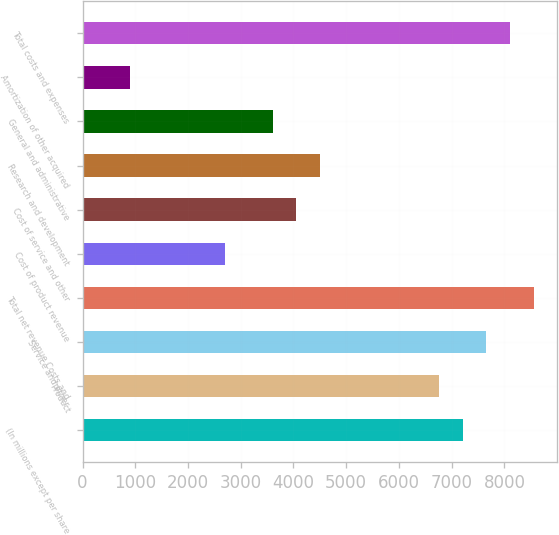Convert chart to OTSL. <chart><loc_0><loc_0><loc_500><loc_500><bar_chart><fcel>(In millions except per share<fcel>Product<fcel>Service and other<fcel>Total net revenue Costs and<fcel>Cost of product revenue<fcel>Cost of service and other<fcel>Research and development<fcel>General and administrative<fcel>Amortization of other acquired<fcel>Total costs and expenses<nl><fcel>7209.44<fcel>6758.86<fcel>7660.02<fcel>8561.18<fcel>2703.64<fcel>4055.38<fcel>4505.96<fcel>3604.8<fcel>901.32<fcel>8110.6<nl></chart> 